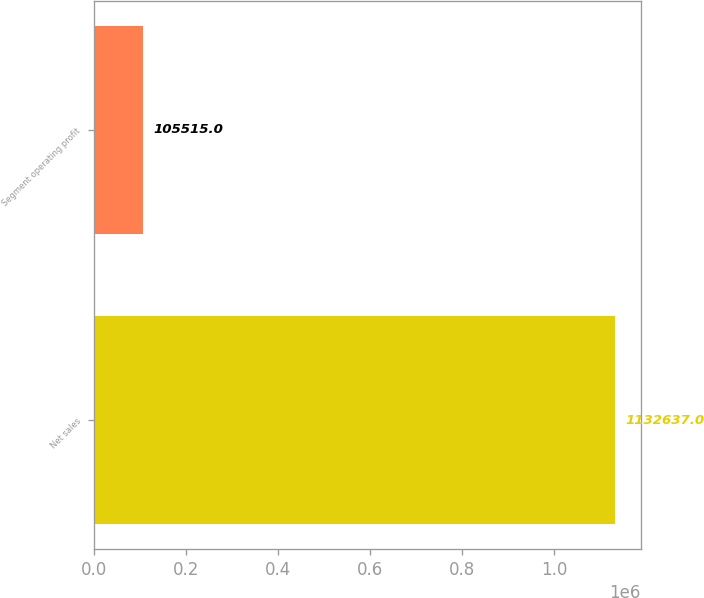<chart> <loc_0><loc_0><loc_500><loc_500><bar_chart><fcel>Net sales<fcel>Segment operating profit<nl><fcel>1.13264e+06<fcel>105515<nl></chart> 